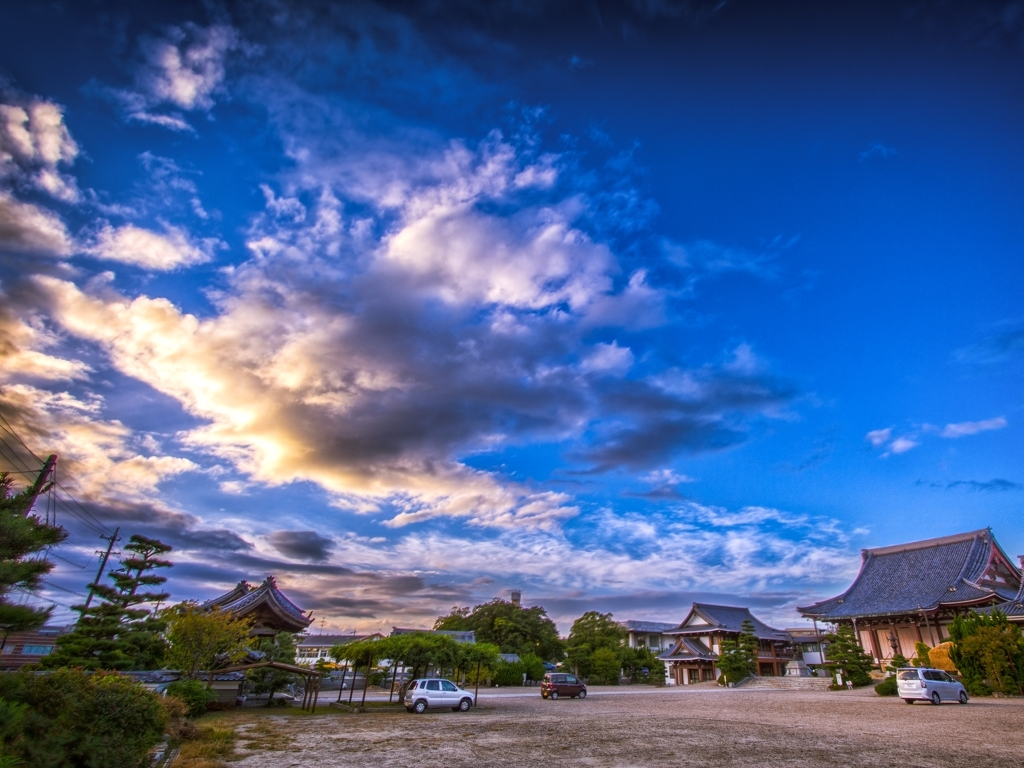What time of day does this image suggest, and what might that say about the possible activities or mood at this location? The image suggests it is either dawn or dusk, times known for their peaceful qualities and beautiful light. This lighting can imply that it is a moment of transition, often associated with quiet contemplation or the beginning of a bustling day. At such a historic and traditional location, the day might start with the preparation of the temple grounds or end with locals and tourists reflecting on the day as they enjoy the picturesque view. 